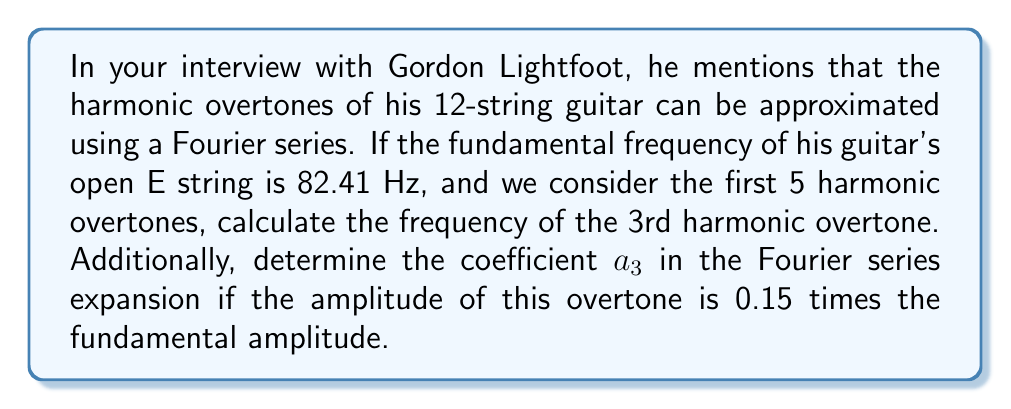Could you help me with this problem? Let's approach this step-by-step:

1) The fundamental frequency $f_0$ is given as 82.41 Hz.

2) Harmonic overtones are integer multiples of the fundamental frequency. The frequencies of the first 5 harmonic overtones are:

   1st overtone: $2f_0 = 2(82.41) = 164.82$ Hz
   2nd overtone: $3f_0 = 3(82.41) = 247.23$ Hz
   3rd overtone: $4f_0 = 4(82.41) = 329.64$ Hz
   4th overtone: $5f_0 = 5(82.41) = 412.05$ Hz
   5th overtone: $6f_0 = 6(82.41) = 494.46$ Hz

3) The question asks for the 3rd harmonic overtone, which is 329.64 Hz.

4) For the Fourier series coefficient, we need to understand that in a Fourier series expansion of a periodic function $f(t)$, the general form is:

   $$f(t) = \frac{a_0}{2} + \sum_{n=1}^{\infty} [a_n \cos(n\omega t) + b_n \sin(n\omega t)]$$

   where $\omega = 2\pi f_0$ is the angular frequency.

5) The amplitude of each harmonic component is related to $\sqrt{a_n^2 + b_n^2}$. In this case, we're told that the amplitude of the 3rd overtone is 0.15 times the fundamental amplitude.

6) If we assume the fundamental has a coefficient of 1 (for simplicity), then:

   $\sqrt{a_3^2 + b_3^2} = 0.15$

7) To find $a_3$, we need additional information about the phase of the overtone. However, if we assume the overtone is a pure cosine (which is a common simplification), then $b_3 = 0$ and $a_3 = 0.15$.
Answer: 329.64 Hz; $a_3 = 0.15$ (assuming pure cosine overtone) 